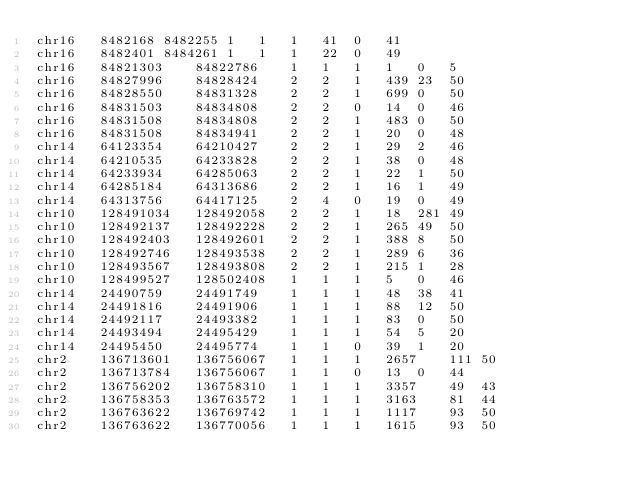Convert code to text. <code><loc_0><loc_0><loc_500><loc_500><_SQL_>chr16	8482168	8482255	1	1	1	41	0	41
chr16	8482401	8484261	1	1	1	22	0	49
chr16	84821303	84822786	1	1	1	1	0	5
chr16	84827996	84828424	2	2	1	439	23	50
chr16	84828550	84831328	2	2	1	699	0	50
chr16	84831503	84834808	2	2	0	14	0	46
chr16	84831508	84834808	2	2	1	483	0	50
chr16	84831508	84834941	2	2	1	20	0	48
chr14	64123354	64210427	2	2	1	29	2	46
chr14	64210535	64233828	2	2	1	38	0	48
chr14	64233934	64285063	2	2	1	22	1	50
chr14	64285184	64313686	2	2	1	16	1	49
chr14	64313756	64417125	2	4	0	19	0	49
chr10	128491034	128492058	2	2	1	18	281	49
chr10	128492137	128492228	2	2	1	265	49	50
chr10	128492403	128492601	2	2	1	388	8	50
chr10	128492746	128493538	2	2	1	289	6	36
chr10	128493567	128493808	2	2	1	215	1	28
chr10	128499527	128502408	1	1	1	5	0	46
chr14	24490759	24491749	1	1	1	48	38	41
chr14	24491816	24491906	1	1	1	88	12	50
chr14	24492117	24493382	1	1	1	83	0	50
chr14	24493494	24495429	1	1	1	54	5	20
chr14	24495450	24495774	1	1	0	39	1	20
chr2	136713601	136756067	1	1	1	2657	111	50
chr2	136713784	136756067	1	1	0	13	0	44
chr2	136756202	136758310	1	1	1	3357	49	43
chr2	136758353	136763572	1	1	1	3163	81	44
chr2	136763622	136769742	1	1	1	1117	93	50
chr2	136763622	136770056	1	1	1	1615	93	50</code> 